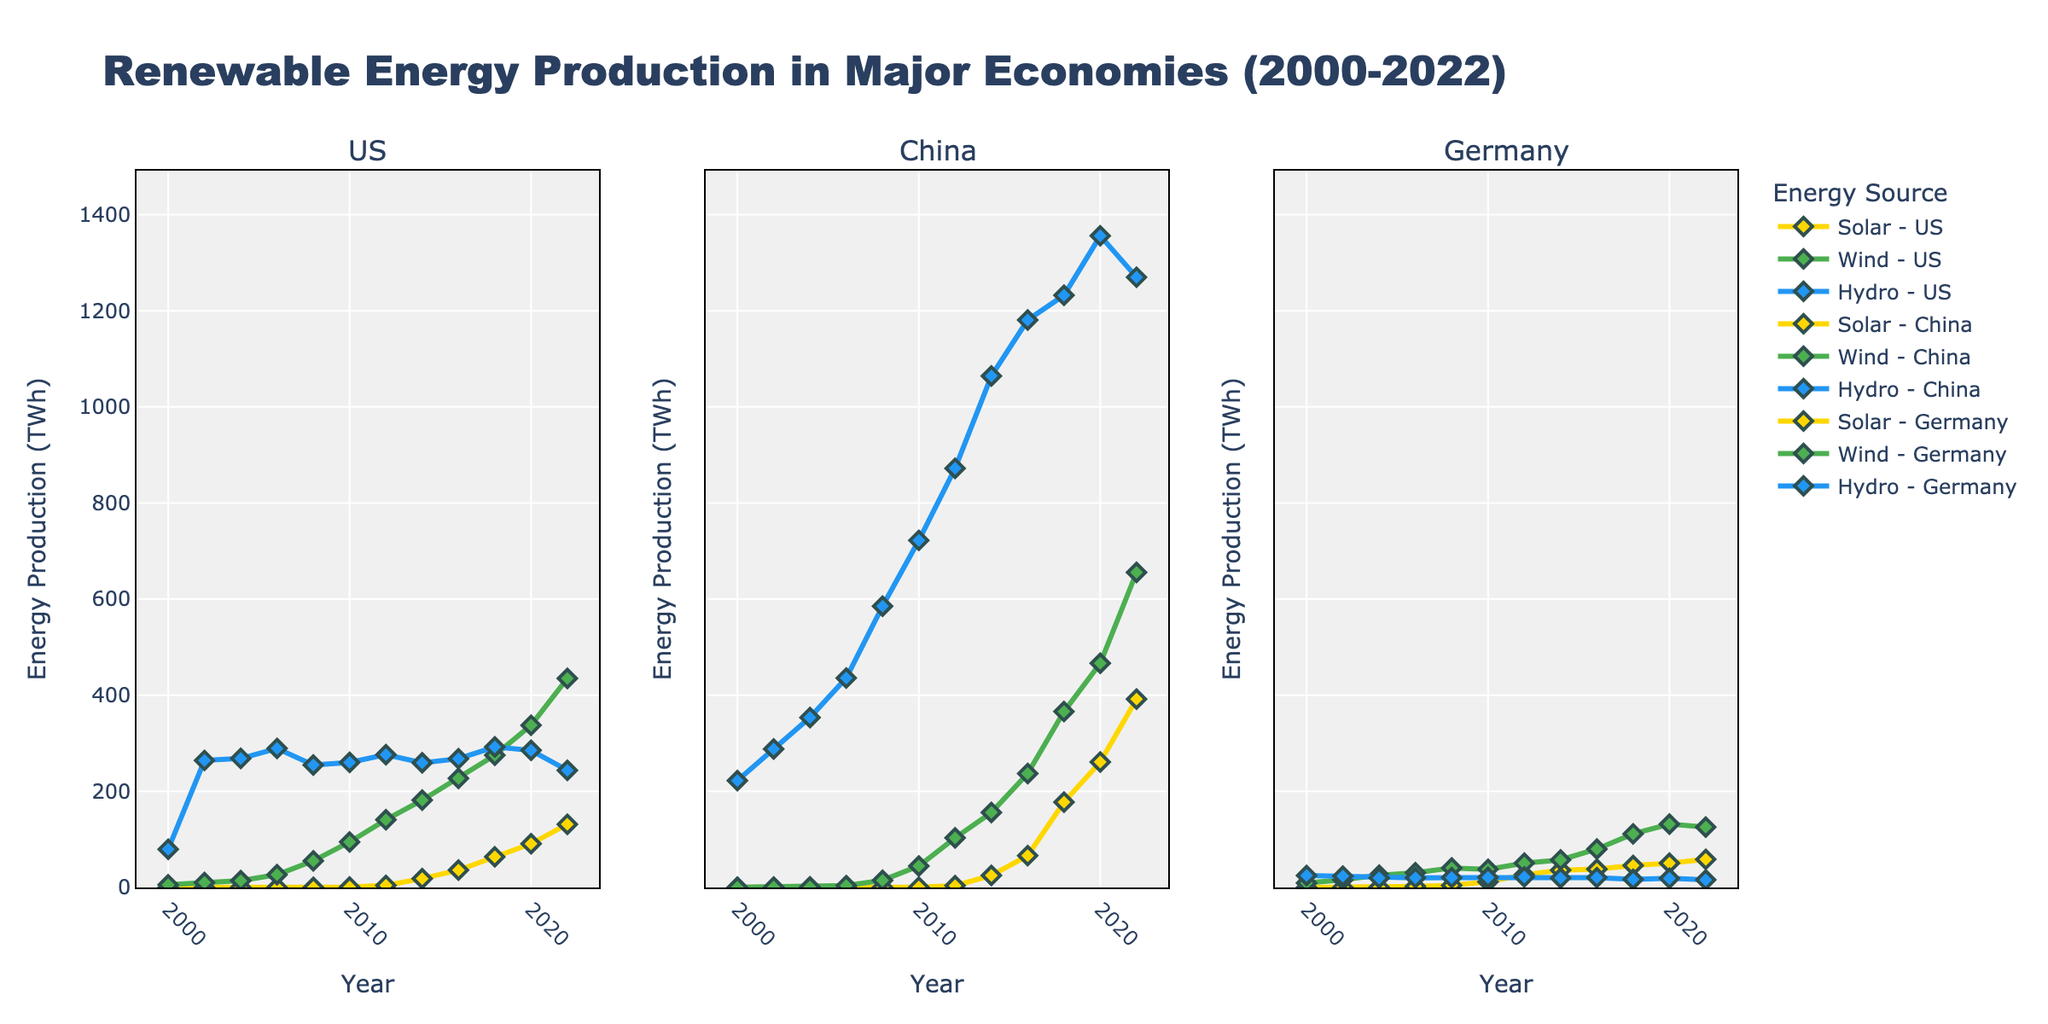Which country had the highest solar energy production in 2022? Observe the end points of the yellow lines (representing solar energy) in each country's plot for the year 2022. The highest point corresponds to China.
Answer: China What was the total wind energy production in Germany over all years presented? Sum the wind energy production values for Germany from the given data across all years. The relevant values are: 9.35, 15.86, 25.51, 30.71, 40.57, 37.79, 50.67, 57.36, 79.93, 111.59, 131.85, 125.68. Adding these gives 716.87 TWh.
Answer: 716.87 TWh Compare the solar energy production between Germany and the US in 2006. Which country had more production? Look at the yellow markers corresponding to the year 2006 for both Germany (2.22 TWh) and the US (0.08 TWh). Germany had more production.
Answer: Germany How did the hydroelectric energy production in the US change from 2000 to 2022? Observe the blue line representing hydroelectric energy for the US. Note the values at 2000 (79.51 TWh) and 2022 (243.69 TWh). The change can be calculated as 243.69 - 79.51 = 164.18 TWh increase.
Answer: Increased by 164.18 TWh For China, which type of renewable energy experienced the most significant growth from 2000 to 2022? Examine the trends of the yellow (solar), green (wind), and blue (hydro) lines for China. Solar energy increased from 0.02 TWh in 2000 to 392.0 TWh in 2022 which is the largest absolute growth.
Answer: Solar energy During which year did the US's wind energy production surpass 300 TWh for the first time? Look at the green line for the US and identify the first year it crosses the 300 TWh mark. This occurs in 2020 (337.51 TWh).
Answer: 2020 Which country had the least hydroelectric energy production in 2020? Compare the blue markers for all three countries in 2020: US (285.28 TWh), China (1355.83 TWh), Germany (18.97 TWh). Germany has the least production.
Answer: Germany How did the wind energy production in China change from 2018 to 2020, and by how much did it increase? Look at the green markers for China at 2018 (366.02 TWh) and 2020 (466.54 TWh). The increase is 466.54 - 366.02 = 100.52 TWh.
Answer: Increased by 100.52 TWh What year did Germany's solar energy production exceed 30 TWh for the first time? Trace the yellow line for Germany to find when it first crosses 30 TWh. The value crosses after 2012 and before 2014. In 2014, it is at 36.06 TWh.
Answer: 2014 